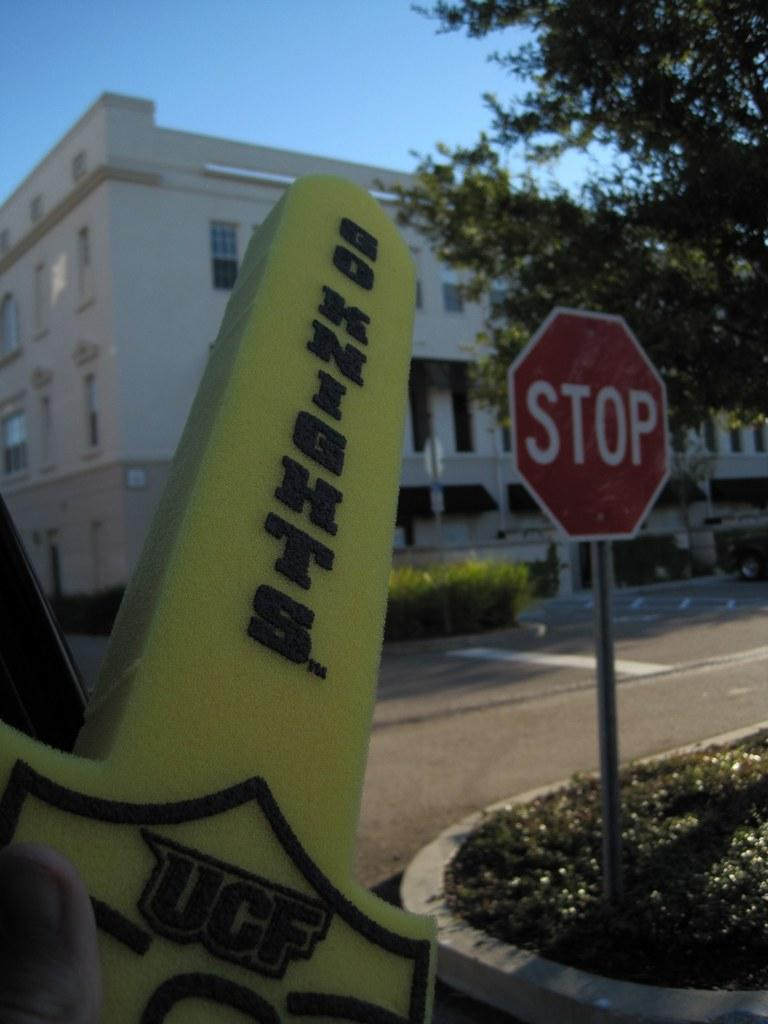What is the main object on the right side of the image? There is a stop sign on the right side of the image. Where is the stop sign located? The stop sign is on the grass. What can be seen in the background of the image? There is a building in the background of the image. What type of vegetation is present in front of the building? There are plants and trees in front of the building. What is visible above the building? The sky is visible above the building. What type of clam is being used as a faucet in the image? There is no clam or faucet present in the image. What religious symbol can be seen on the stop sign in the image? There is no religious symbol on the stop sign in the image; it is a standard traffic sign. 